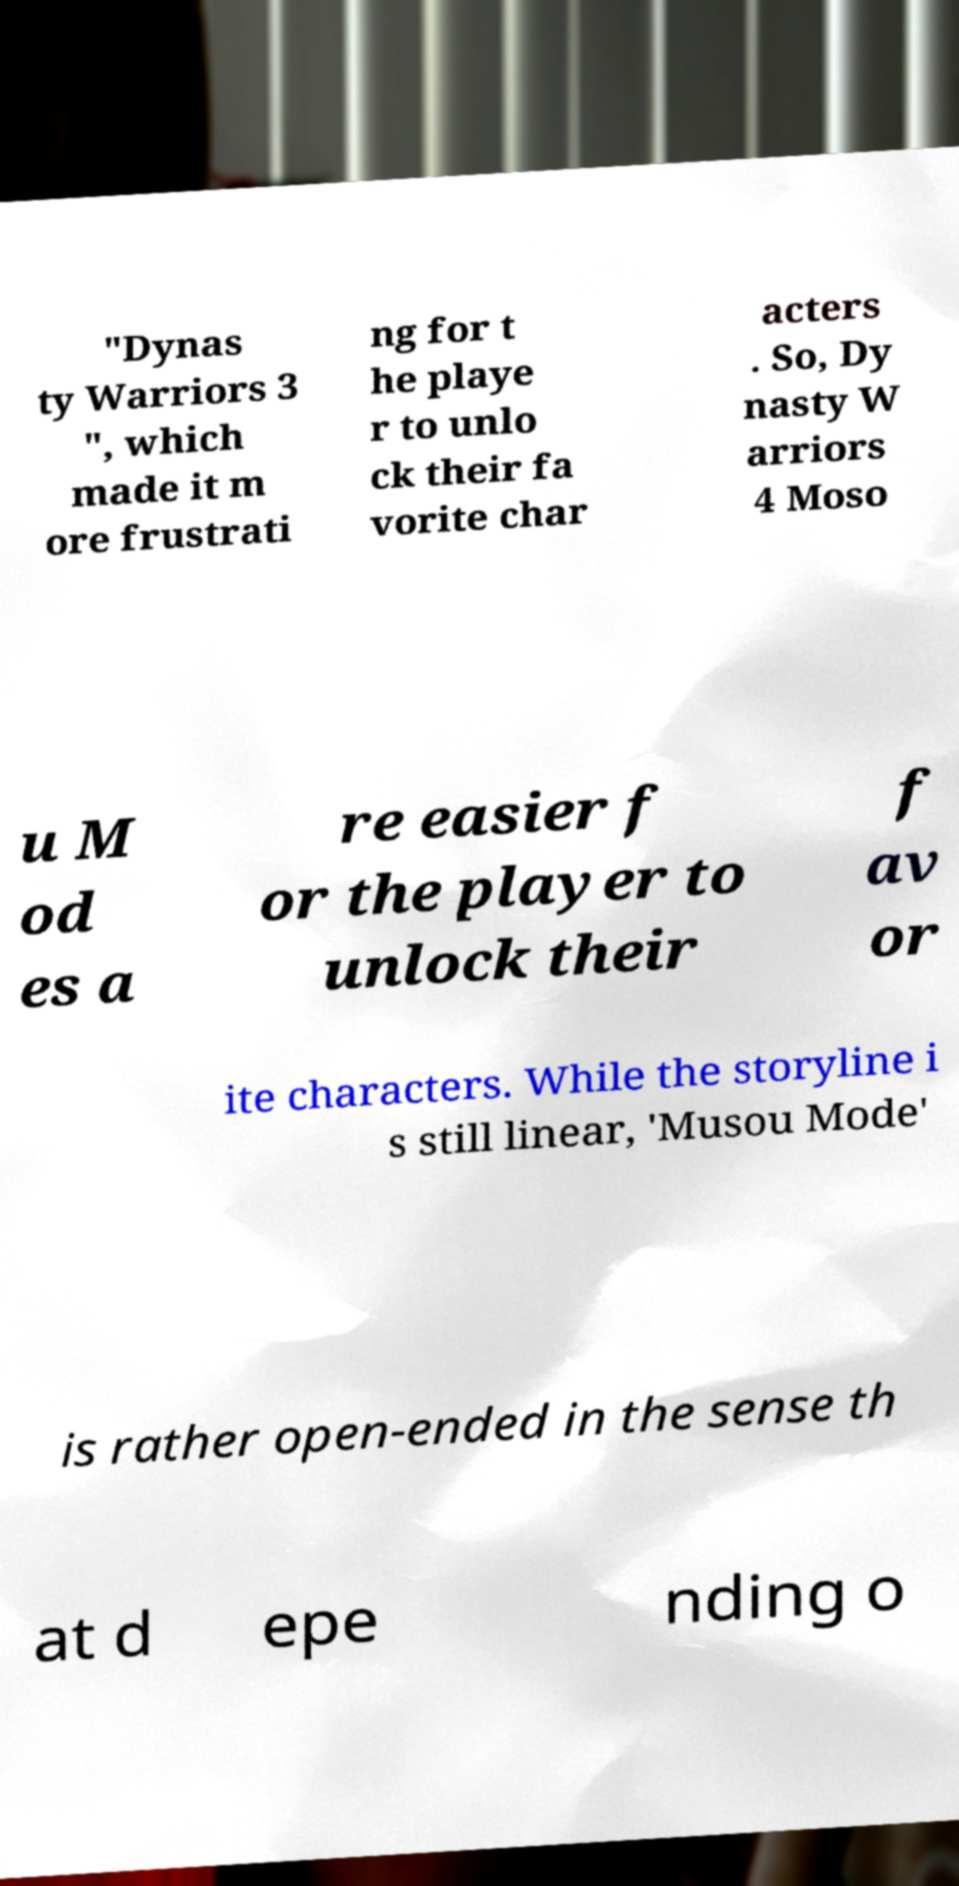Please read and relay the text visible in this image. What does it say? "Dynas ty Warriors 3 ", which made it m ore frustrati ng for t he playe r to unlo ck their fa vorite char acters . So, Dy nasty W arriors 4 Moso u M od es a re easier f or the player to unlock their f av or ite characters. While the storyline i s still linear, 'Musou Mode' is rather open-ended in the sense th at d epe nding o 